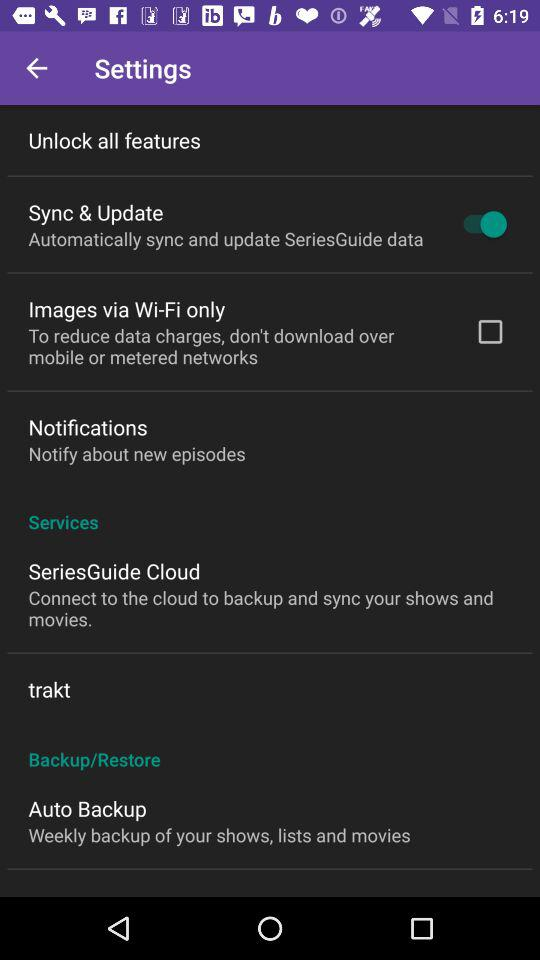How often does the SeriesGuide back up data? The SeriesGuide app performs a weekly backup of your shows, lists, and movies, as specified in the settings under 'Auto Backup'. 